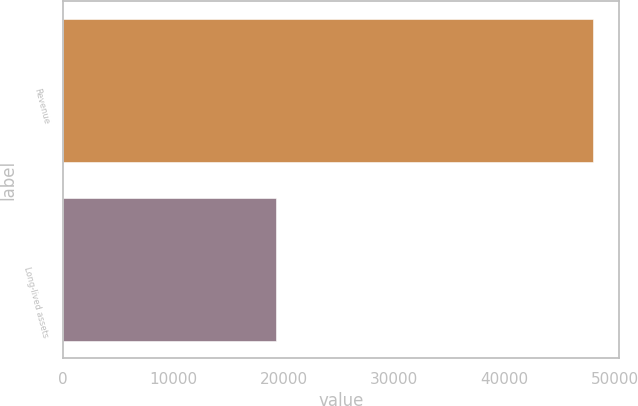Convert chart. <chart><loc_0><loc_0><loc_500><loc_500><bar_chart><fcel>Revenue<fcel>Long-lived assets<nl><fcel>48013<fcel>19253<nl></chart> 